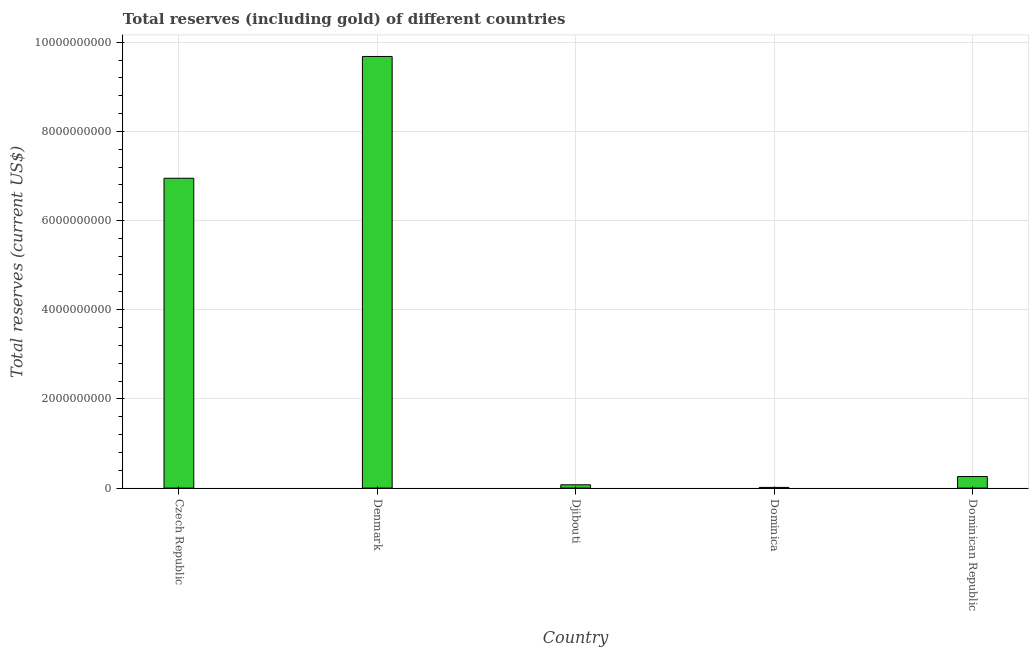Does the graph contain grids?
Make the answer very short. Yes. What is the title of the graph?
Your response must be concise. Total reserves (including gold) of different countries. What is the label or title of the X-axis?
Give a very brief answer. Country. What is the label or title of the Y-axis?
Provide a succinct answer. Total reserves (current US$). What is the total reserves (including gold) in Denmark?
Your answer should be very brief. 9.68e+09. Across all countries, what is the maximum total reserves (including gold)?
Your answer should be very brief. 9.68e+09. Across all countries, what is the minimum total reserves (including gold)?
Provide a succinct answer. 1.54e+07. In which country was the total reserves (including gold) maximum?
Your answer should be very brief. Denmark. In which country was the total reserves (including gold) minimum?
Your answer should be compact. Dominica. What is the sum of the total reserves (including gold)?
Make the answer very short. 1.70e+1. What is the difference between the total reserves (including gold) in Djibouti and Dominica?
Keep it short and to the point. 5.83e+07. What is the average total reserves (including gold) per country?
Ensure brevity in your answer.  3.40e+09. What is the median total reserves (including gold)?
Offer a terse response. 2.59e+08. In how many countries, is the total reserves (including gold) greater than 6400000000 US$?
Offer a very short reply. 2. What is the ratio of the total reserves (including gold) in Czech Republic to that in Dominican Republic?
Your answer should be compact. 26.82. What is the difference between the highest and the second highest total reserves (including gold)?
Provide a succinct answer. 2.73e+09. What is the difference between the highest and the lowest total reserves (including gold)?
Your answer should be compact. 9.66e+09. How many bars are there?
Keep it short and to the point. 5. Are all the bars in the graph horizontal?
Offer a terse response. No. What is the Total reserves (current US$) in Czech Republic?
Make the answer very short. 6.95e+09. What is the Total reserves (current US$) in Denmark?
Keep it short and to the point. 9.68e+09. What is the Total reserves (current US$) in Djibouti?
Make the answer very short. 7.38e+07. What is the Total reserves (current US$) in Dominica?
Your answer should be compact. 1.54e+07. What is the Total reserves (current US$) of Dominican Republic?
Give a very brief answer. 2.59e+08. What is the difference between the Total reserves (current US$) in Czech Republic and Denmark?
Keep it short and to the point. -2.73e+09. What is the difference between the Total reserves (current US$) in Czech Republic and Djibouti?
Give a very brief answer. 6.87e+09. What is the difference between the Total reserves (current US$) in Czech Republic and Dominica?
Your answer should be very brief. 6.93e+09. What is the difference between the Total reserves (current US$) in Czech Republic and Dominican Republic?
Offer a terse response. 6.69e+09. What is the difference between the Total reserves (current US$) in Denmark and Djibouti?
Your response must be concise. 9.61e+09. What is the difference between the Total reserves (current US$) in Denmark and Dominica?
Make the answer very short. 9.66e+09. What is the difference between the Total reserves (current US$) in Denmark and Dominican Republic?
Provide a short and direct response. 9.42e+09. What is the difference between the Total reserves (current US$) in Djibouti and Dominica?
Provide a short and direct response. 5.83e+07. What is the difference between the Total reserves (current US$) in Djibouti and Dominican Republic?
Your answer should be compact. -1.85e+08. What is the difference between the Total reserves (current US$) in Dominica and Dominican Republic?
Offer a very short reply. -2.44e+08. What is the ratio of the Total reserves (current US$) in Czech Republic to that in Denmark?
Give a very brief answer. 0.72. What is the ratio of the Total reserves (current US$) in Czech Republic to that in Djibouti?
Offer a terse response. 94.21. What is the ratio of the Total reserves (current US$) in Czech Republic to that in Dominica?
Keep it short and to the point. 450.77. What is the ratio of the Total reserves (current US$) in Czech Republic to that in Dominican Republic?
Make the answer very short. 26.82. What is the ratio of the Total reserves (current US$) in Denmark to that in Djibouti?
Offer a very short reply. 131.24. What is the ratio of the Total reserves (current US$) in Denmark to that in Dominica?
Provide a succinct answer. 627.98. What is the ratio of the Total reserves (current US$) in Denmark to that in Dominican Republic?
Offer a very short reply. 37.36. What is the ratio of the Total reserves (current US$) in Djibouti to that in Dominica?
Keep it short and to the point. 4.79. What is the ratio of the Total reserves (current US$) in Djibouti to that in Dominican Republic?
Offer a terse response. 0.28. What is the ratio of the Total reserves (current US$) in Dominica to that in Dominican Republic?
Offer a very short reply. 0.06. 